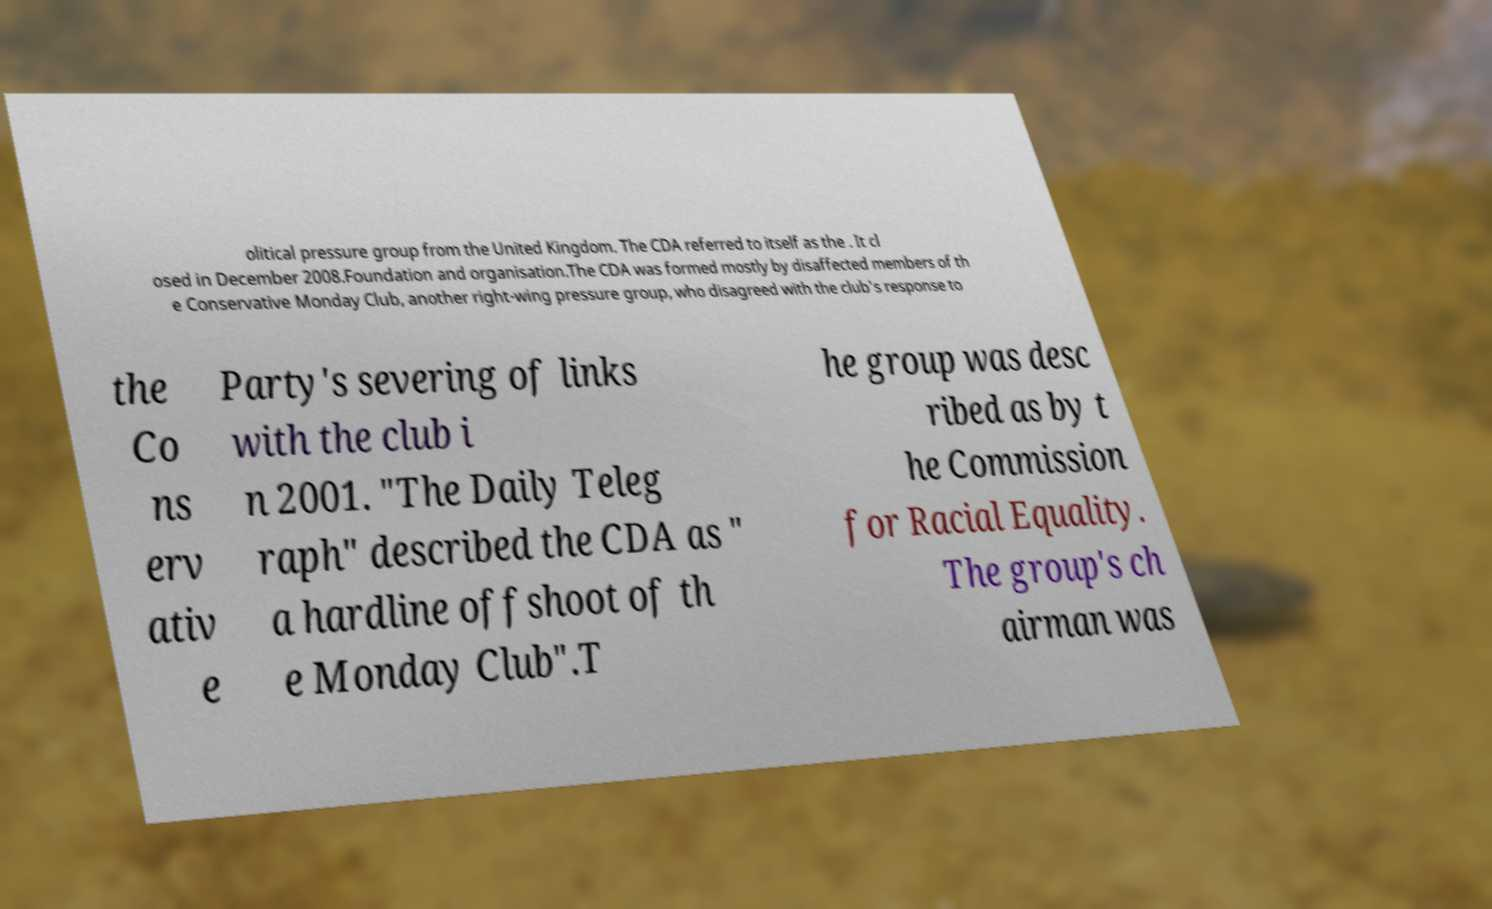Could you assist in decoding the text presented in this image and type it out clearly? olitical pressure group from the United Kingdom. The CDA referred to itself as the . It cl osed in December 2008.Foundation and organisation.The CDA was formed mostly by disaffected members of th e Conservative Monday Club, another right-wing pressure group, who disagreed with the club's response to the Co ns erv ativ e Party's severing of links with the club i n 2001. "The Daily Teleg raph" described the CDA as " a hardline offshoot of th e Monday Club".T he group was desc ribed as by t he Commission for Racial Equality. The group's ch airman was 